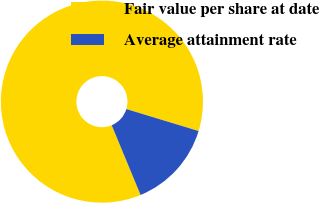Convert chart. <chart><loc_0><loc_0><loc_500><loc_500><pie_chart><fcel>Fair value per share at date<fcel>Average attainment rate<nl><fcel>85.95%<fcel>14.05%<nl></chart> 